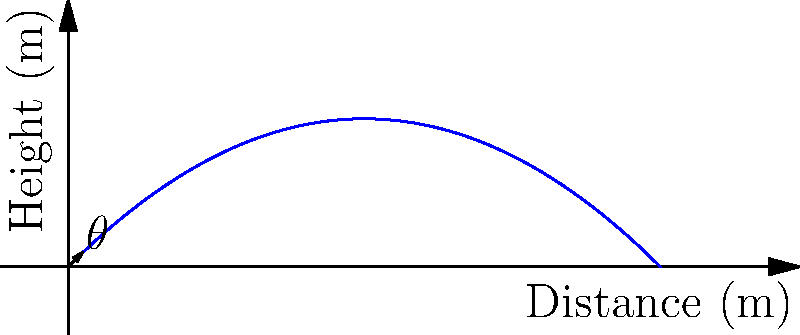In a quick break between meetings, you observe a maintenance worker tossing a small object. The object's path reminds you of a concept from physics. If the initial velocity is 20 m/s at a 45° angle, what is the maximum height reached by the object? (Assume g = 9.8 m/s²) Let's approach this step-by-step:

1) The maximum height is reached when the vertical velocity becomes zero. We can use the equation:

   $$v_y = v_0 \sin(\theta) - gt$$

2) At the highest point, $v_y = 0$, so:

   $$0 = v_0 \sin(\theta) - gt_{max}$$

3) Solving for $t_{max}$:

   $$t_{max} = \frac{v_0 \sin(\theta)}{g}$$

4) Substituting the given values:

   $$t_{max} = \frac{20 \sin(45°)}{9.8} \approx 1.44 \text{ s}$$

5) Now, we can use the equation for height:

   $$y = v_0 \sin(\theta)t - \frac{1}{2}gt^2$$

6) Substituting $t_{max}$ into this equation:

   $$y_{max} = 20 \sin(45°)(1.44) - \frac{1}{2}(9.8)(1.44)^2$$

7) Simplifying:

   $$y_{max} = 20.4 - 10.2 = 10.2 \text{ m}$$

Therefore, the maximum height reached is approximately 10.2 meters.
Answer: 10.2 m 